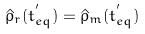<formula> <loc_0><loc_0><loc_500><loc_500>\hat { \rho } _ { r } ( t ^ { ^ { \prime } } _ { e q } ) = \hat { \rho } _ { m } ( t ^ { ^ { \prime } } _ { e q } )</formula> 